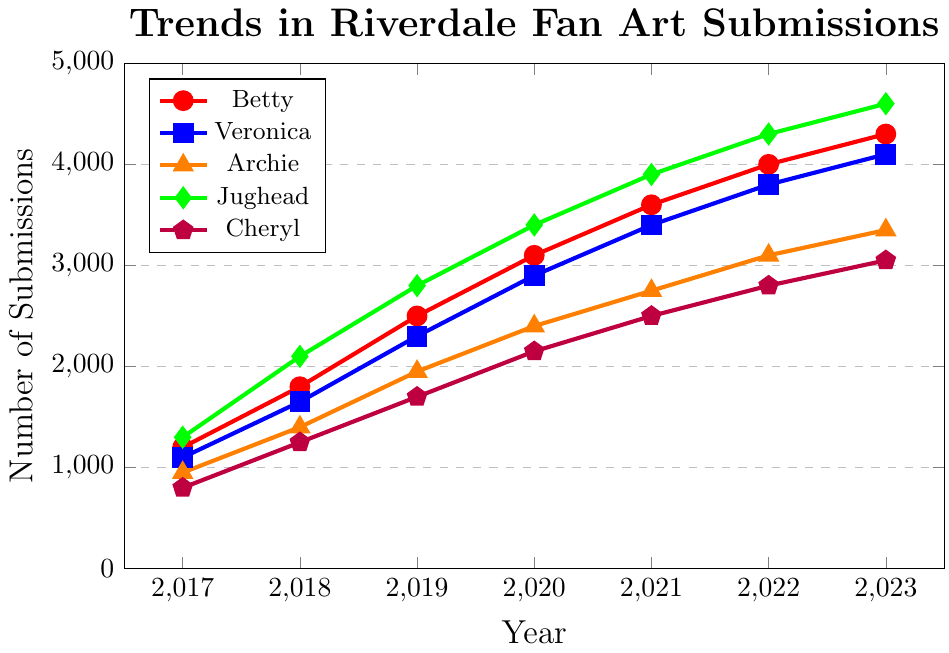Which character had the highest number of fan art submissions in 2023? To find the character with the highest number of submissions in 2023, observe the data points for each character in that year. Jughead had the highest submissions with 4600.
Answer: Jughead Which year did Betty have the biggest increase in submissions compared to the previous year? To determine the year with the biggest increase for Betty, calculate the differences between consecutive years. The increases are: 2018-2017: 600, 2019-2018: 700, 2020-2019: 600, 2021-2020: 500, 2022-2021: 400, 2023-2022: 300. The largest increase was between 2018 and 2019 (700).
Answer: 2019 Which character had the least amount of fan art submissions in 2017? Look at the values for each character in 2017. Cheryl had the least submissions with 800.
Answer: Cheryl What is the total number of fan art submissions for Veronica and Archie combined in 2022? Add the number of submissions for Veronica and Archie in 2022: 3800 (Veronica) + 3100 (Archie) = 6900.
Answer: 6900 Did any character have a year where submissions decreased compared to the previous year? Review the submissions data for all characters year by year. There are no decreases; all characters show a steady increase each year.
Answer: No How many more submissions did Jughead have than Veronica in 2020? Calculate the difference in submissions between Jughead and Veronica in 2020: 3400 (Jughead) - 2900 (Veronica) = 500.
Answer: 500 Which character showed the highest consistent annual growth rate from 2017 to 2023? Check the increase per year for each character and determine the consistency. Jughead has consistently shown a significant increase every year, with the increments sustaining a higer percentage compared to others.
Answer: Jughead What's the average number of fan art submissions for Cheryl between 2017 and 2023? Find the sum of submissions for Cheryl for all years and divide by the number of years: (800 + 1250 + 1700 + 2150 + 2500 + 2800 + 3050) / 7 = 1750.
Answer: 1750 Between Betty and Archie, whose submissions grew faster from 2018 to 2023? Calculate the difference over the years for both Betty and Archie: For Betty from 2018 (1800) to 2023 (4300) the growth is 2500. For Archie from 2018 (1400) to 2023 (3350) the growth is 1950. Betty's submissions grew faster.
Answer: Betty 